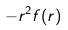Convert formula to latex. <formula><loc_0><loc_0><loc_500><loc_500>- r ^ { 2 } f ( r )</formula> 